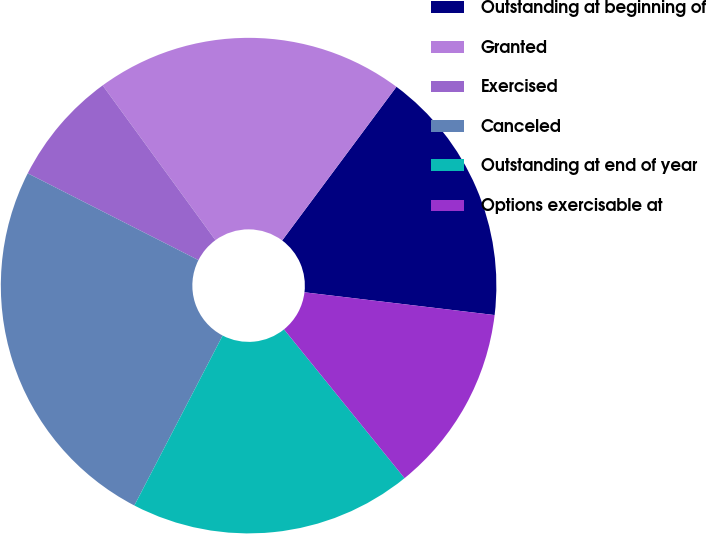<chart> <loc_0><loc_0><loc_500><loc_500><pie_chart><fcel>Outstanding at beginning of<fcel>Granted<fcel>Exercised<fcel>Canceled<fcel>Outstanding at end of year<fcel>Options exercisable at<nl><fcel>16.72%<fcel>20.2%<fcel>7.49%<fcel>24.86%<fcel>18.46%<fcel>12.27%<nl></chart> 